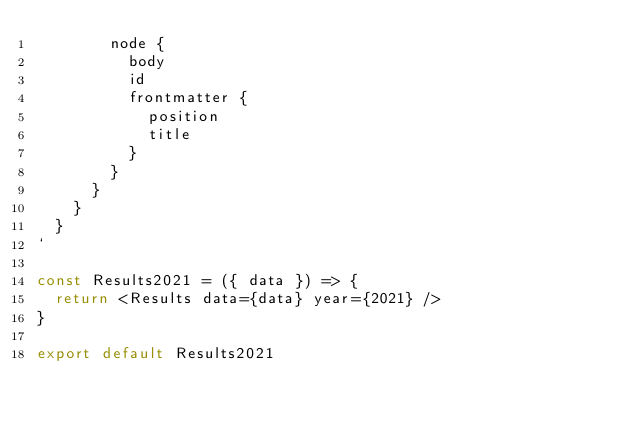<code> <loc_0><loc_0><loc_500><loc_500><_JavaScript_>        node {
          body
          id
          frontmatter {
            position
            title
          }
        }
      }
    }
  }
`

const Results2021 = ({ data }) => {
  return <Results data={data} year={2021} />
}

export default Results2021
</code> 